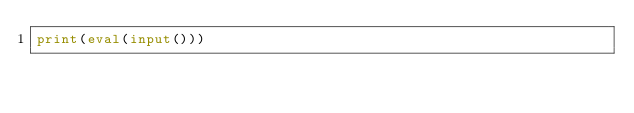<code> <loc_0><loc_0><loc_500><loc_500><_Python_>print(eval(input()))</code> 